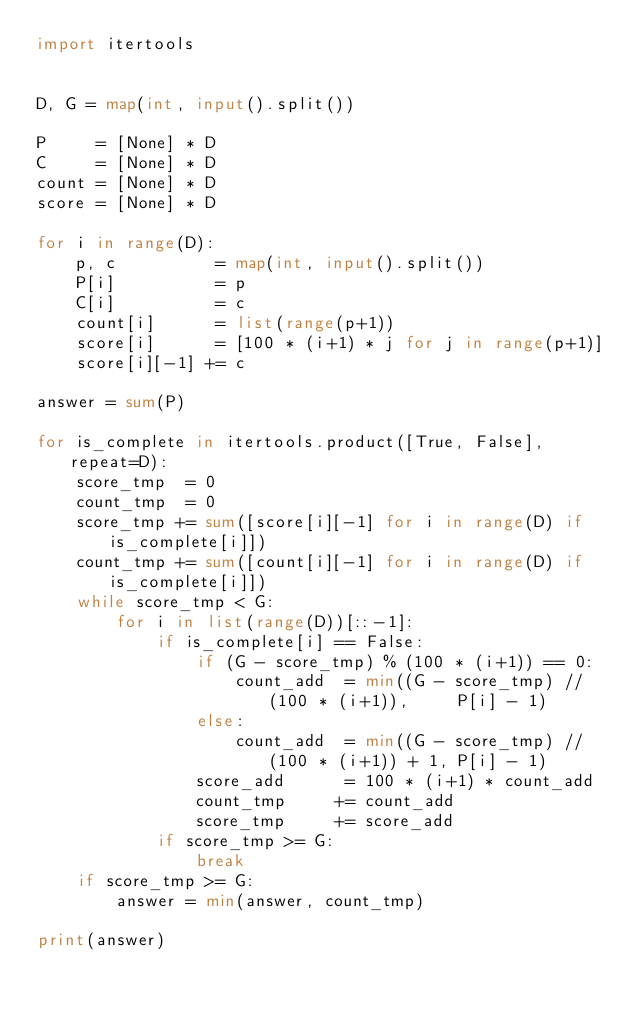<code> <loc_0><loc_0><loc_500><loc_500><_Python_>import itertools


D, G = map(int, input().split())

P     = [None] * D
C     = [None] * D
count = [None] * D
score = [None] * D

for i in range(D):
    p, c          = map(int, input().split())
    P[i]          = p
    C[i]          = c
    count[i]      = list(range(p+1))
    score[i]      = [100 * (i+1) * j for j in range(p+1)]
    score[i][-1] += c

answer = sum(P)

for is_complete in itertools.product([True, False], repeat=D):
    score_tmp  = 0
    count_tmp  = 0
    score_tmp += sum([score[i][-1] for i in range(D) if is_complete[i]])
    count_tmp += sum([count[i][-1] for i in range(D) if is_complete[i]])
    while score_tmp < G:
        for i in list(range(D))[::-1]:
            if is_complete[i] == False:
                if (G - score_tmp) % (100 * (i+1)) == 0:
                    count_add  = min((G - score_tmp) // (100 * (i+1)),     P[i] - 1)
                else:
                    count_add  = min((G - score_tmp) // (100 * (i+1)) + 1, P[i] - 1)
                score_add      = 100 * (i+1) * count_add
                count_tmp     += count_add
                score_tmp     += score_add
            if score_tmp >= G:
                break
    if score_tmp >= G:
        answer = min(answer, count_tmp)

print(answer)
</code> 